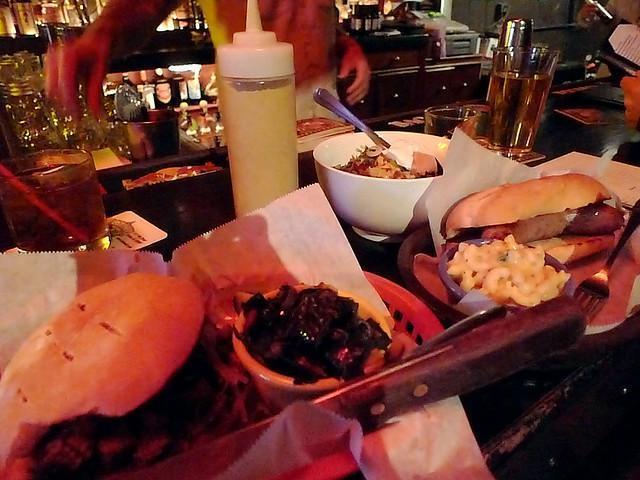How many bowls are there?
Give a very brief answer. 3. How many knives can you see?
Give a very brief answer. 2. How many cups can you see?
Give a very brief answer. 2. How many dining tables are visible?
Give a very brief answer. 1. How many airplanes are there?
Give a very brief answer. 0. 